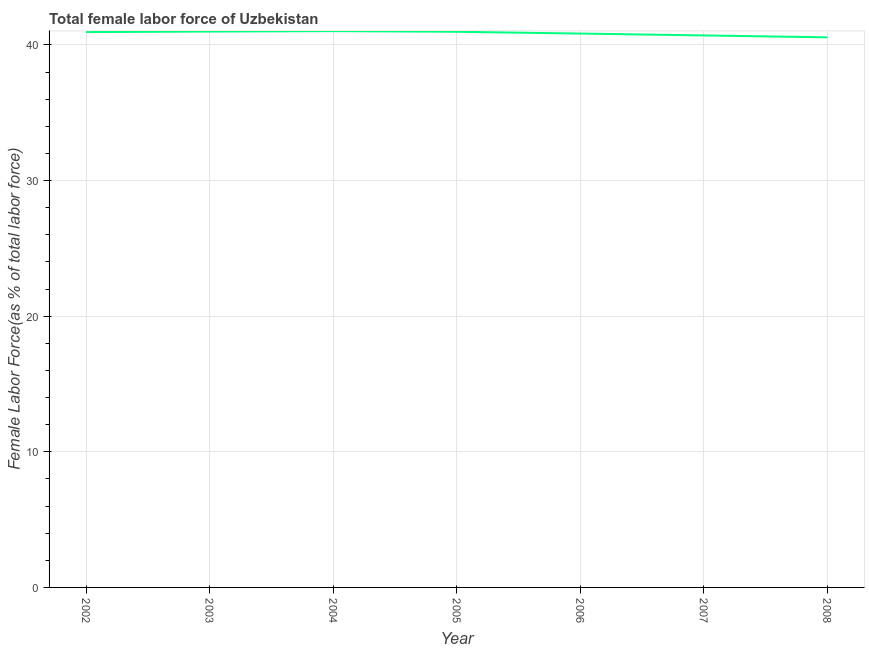What is the total female labor force in 2008?
Your answer should be very brief. 40.56. Across all years, what is the maximum total female labor force?
Keep it short and to the point. 41.01. Across all years, what is the minimum total female labor force?
Provide a succinct answer. 40.56. In which year was the total female labor force minimum?
Your answer should be very brief. 2008. What is the sum of the total female labor force?
Ensure brevity in your answer.  286. What is the difference between the total female labor force in 2002 and 2006?
Make the answer very short. 0.11. What is the average total female labor force per year?
Provide a succinct answer. 40.86. What is the median total female labor force?
Make the answer very short. 40.95. In how many years, is the total female labor force greater than 26 %?
Make the answer very short. 7. What is the ratio of the total female labor force in 2003 to that in 2004?
Keep it short and to the point. 1. What is the difference between the highest and the second highest total female labor force?
Offer a very short reply. 0.03. Is the sum of the total female labor force in 2004 and 2005 greater than the maximum total female labor force across all years?
Give a very brief answer. Yes. What is the difference between the highest and the lowest total female labor force?
Offer a very short reply. 0.46. In how many years, is the total female labor force greater than the average total female labor force taken over all years?
Provide a short and direct response. 4. Does the total female labor force monotonically increase over the years?
Make the answer very short. No. What is the difference between two consecutive major ticks on the Y-axis?
Make the answer very short. 10. Does the graph contain any zero values?
Ensure brevity in your answer.  No. Does the graph contain grids?
Your answer should be very brief. Yes. What is the title of the graph?
Make the answer very short. Total female labor force of Uzbekistan. What is the label or title of the X-axis?
Keep it short and to the point. Year. What is the label or title of the Y-axis?
Your answer should be compact. Female Labor Force(as % of total labor force). What is the Female Labor Force(as % of total labor force) of 2002?
Your answer should be compact. 40.95. What is the Female Labor Force(as % of total labor force) of 2003?
Make the answer very short. 40.98. What is the Female Labor Force(as % of total labor force) of 2004?
Your answer should be compact. 41.01. What is the Female Labor Force(as % of total labor force) of 2005?
Provide a succinct answer. 40.97. What is the Female Labor Force(as % of total labor force) in 2006?
Provide a succinct answer. 40.84. What is the Female Labor Force(as % of total labor force) of 2007?
Offer a very short reply. 40.7. What is the Female Labor Force(as % of total labor force) in 2008?
Provide a succinct answer. 40.56. What is the difference between the Female Labor Force(as % of total labor force) in 2002 and 2003?
Offer a terse response. -0.04. What is the difference between the Female Labor Force(as % of total labor force) in 2002 and 2004?
Your answer should be very brief. -0.07. What is the difference between the Female Labor Force(as % of total labor force) in 2002 and 2005?
Your answer should be compact. -0.02. What is the difference between the Female Labor Force(as % of total labor force) in 2002 and 2006?
Offer a terse response. 0.11. What is the difference between the Female Labor Force(as % of total labor force) in 2002 and 2007?
Make the answer very short. 0.25. What is the difference between the Female Labor Force(as % of total labor force) in 2002 and 2008?
Offer a very short reply. 0.39. What is the difference between the Female Labor Force(as % of total labor force) in 2003 and 2004?
Your response must be concise. -0.03. What is the difference between the Female Labor Force(as % of total labor force) in 2003 and 2005?
Provide a short and direct response. 0.02. What is the difference between the Female Labor Force(as % of total labor force) in 2003 and 2006?
Your response must be concise. 0.15. What is the difference between the Female Labor Force(as % of total labor force) in 2003 and 2007?
Your response must be concise. 0.29. What is the difference between the Female Labor Force(as % of total labor force) in 2003 and 2008?
Provide a short and direct response. 0.43. What is the difference between the Female Labor Force(as % of total labor force) in 2004 and 2005?
Your answer should be compact. 0.05. What is the difference between the Female Labor Force(as % of total labor force) in 2004 and 2006?
Provide a short and direct response. 0.18. What is the difference between the Female Labor Force(as % of total labor force) in 2004 and 2007?
Your response must be concise. 0.32. What is the difference between the Female Labor Force(as % of total labor force) in 2004 and 2008?
Your answer should be very brief. 0.46. What is the difference between the Female Labor Force(as % of total labor force) in 2005 and 2006?
Provide a short and direct response. 0.13. What is the difference between the Female Labor Force(as % of total labor force) in 2005 and 2007?
Make the answer very short. 0.27. What is the difference between the Female Labor Force(as % of total labor force) in 2005 and 2008?
Your answer should be compact. 0.41. What is the difference between the Female Labor Force(as % of total labor force) in 2006 and 2007?
Provide a succinct answer. 0.14. What is the difference between the Female Labor Force(as % of total labor force) in 2006 and 2008?
Your response must be concise. 0.28. What is the difference between the Female Labor Force(as % of total labor force) in 2007 and 2008?
Keep it short and to the point. 0.14. What is the ratio of the Female Labor Force(as % of total labor force) in 2002 to that in 2003?
Your response must be concise. 1. What is the ratio of the Female Labor Force(as % of total labor force) in 2002 to that in 2005?
Keep it short and to the point. 1. What is the ratio of the Female Labor Force(as % of total labor force) in 2002 to that in 2006?
Give a very brief answer. 1. What is the ratio of the Female Labor Force(as % of total labor force) in 2002 to that in 2007?
Provide a short and direct response. 1.01. What is the ratio of the Female Labor Force(as % of total labor force) in 2002 to that in 2008?
Give a very brief answer. 1.01. What is the ratio of the Female Labor Force(as % of total labor force) in 2003 to that in 2004?
Offer a terse response. 1. What is the ratio of the Female Labor Force(as % of total labor force) in 2003 to that in 2005?
Offer a very short reply. 1. What is the ratio of the Female Labor Force(as % of total labor force) in 2003 to that in 2006?
Your answer should be compact. 1. What is the ratio of the Female Labor Force(as % of total labor force) in 2003 to that in 2007?
Your response must be concise. 1.01. What is the ratio of the Female Labor Force(as % of total labor force) in 2004 to that in 2005?
Make the answer very short. 1. What is the ratio of the Female Labor Force(as % of total labor force) in 2004 to that in 2007?
Provide a short and direct response. 1.01. What is the ratio of the Female Labor Force(as % of total labor force) in 2004 to that in 2008?
Keep it short and to the point. 1.01. What is the ratio of the Female Labor Force(as % of total labor force) in 2005 to that in 2008?
Provide a succinct answer. 1.01. What is the ratio of the Female Labor Force(as % of total labor force) in 2007 to that in 2008?
Your answer should be very brief. 1. 